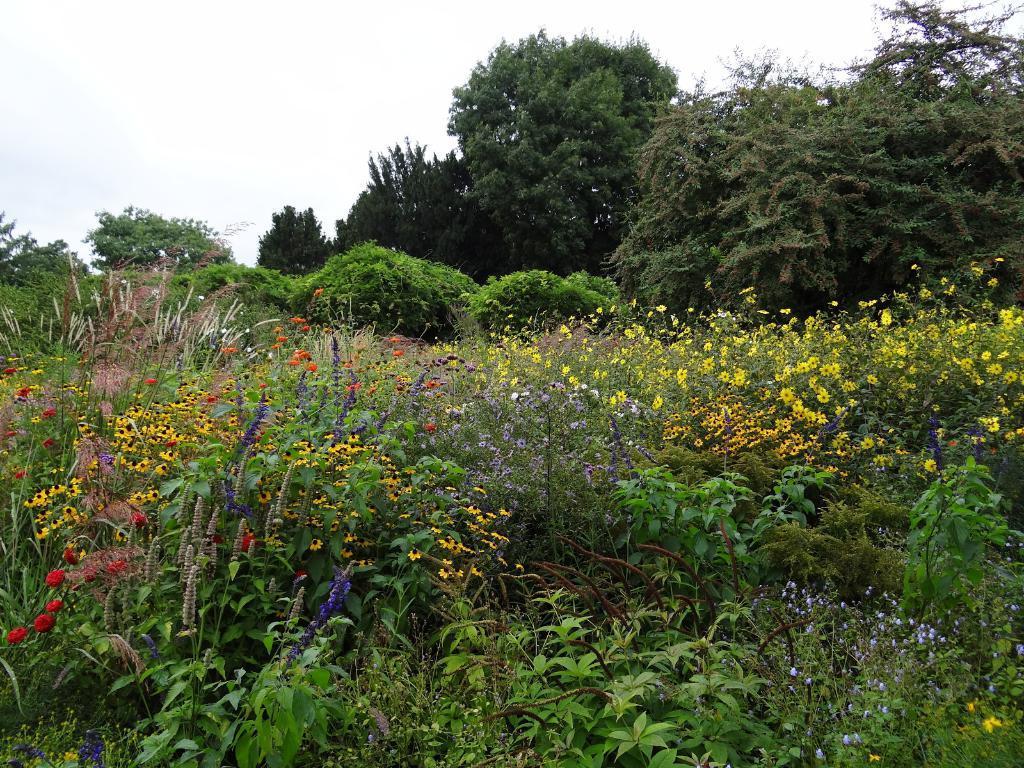Could you give a brief overview of what you see in this image? In this image there is a beautiful garden with flowers and in the background there are trees and cloudy sky. 